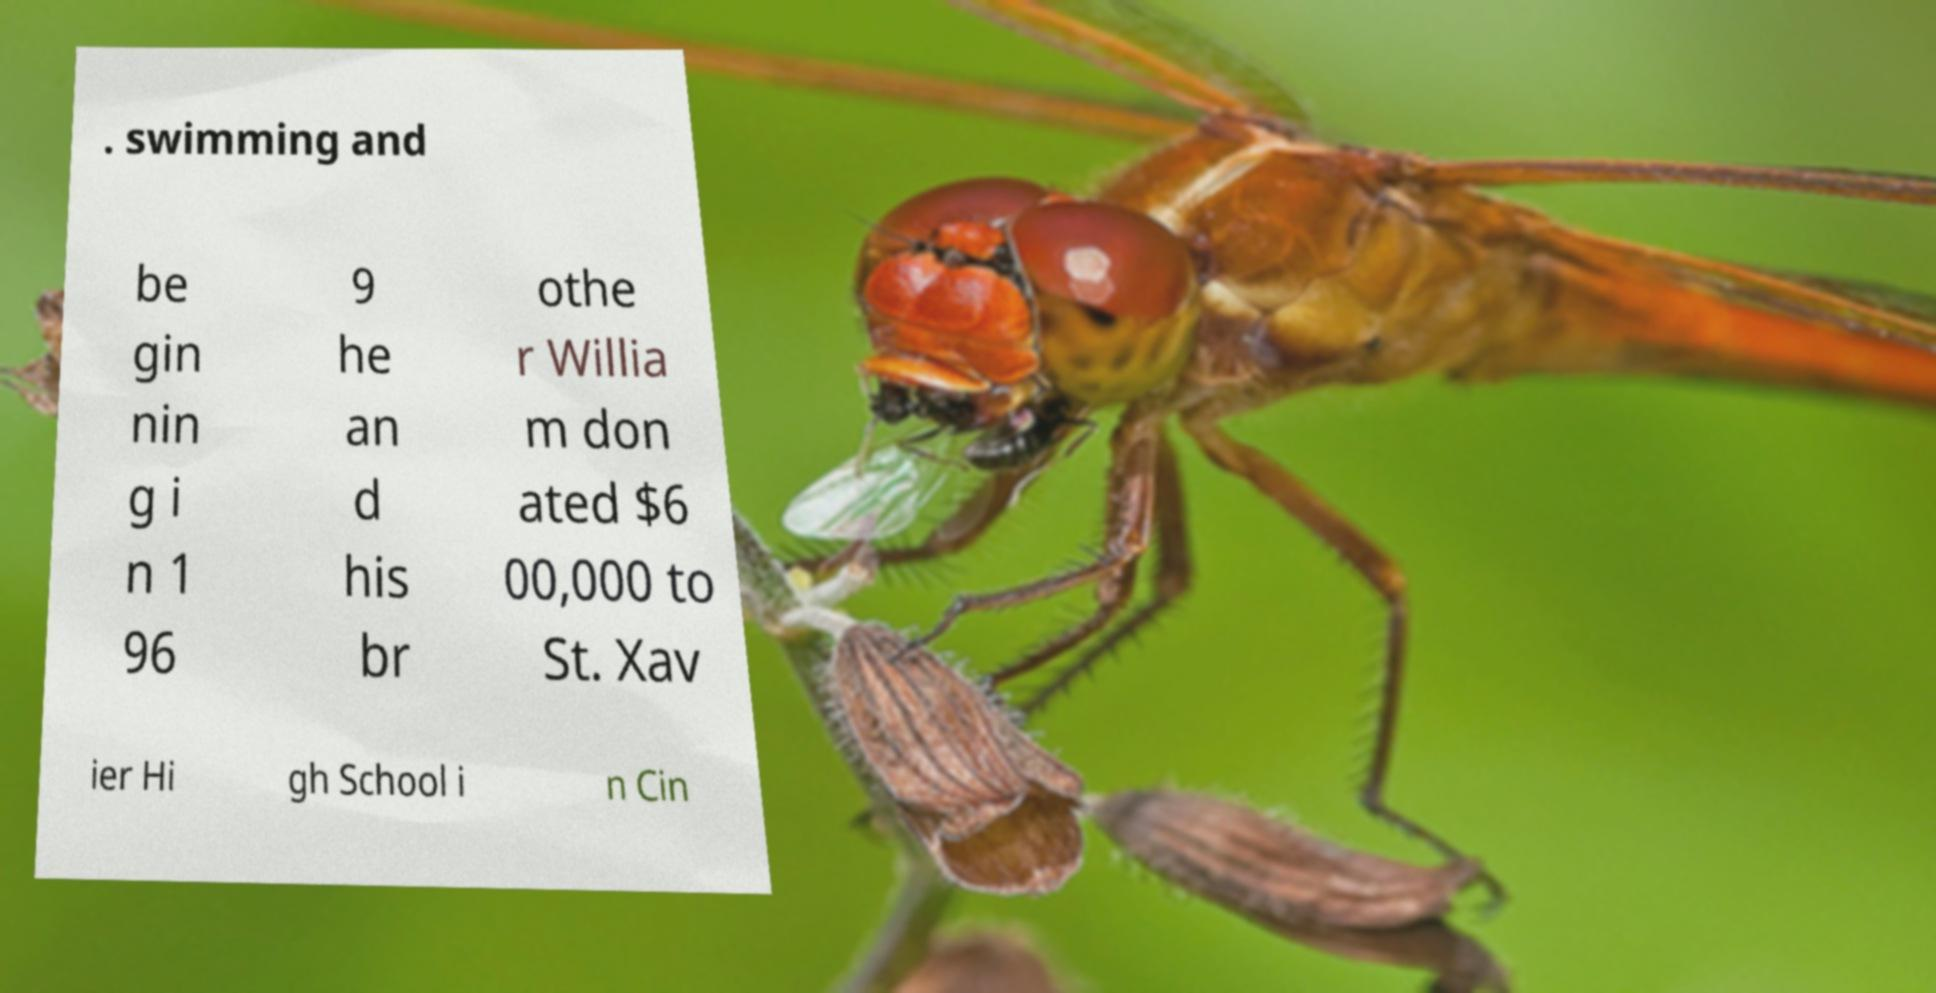For documentation purposes, I need the text within this image transcribed. Could you provide that? . swimming and be gin nin g i n 1 96 9 he an d his br othe r Willia m don ated $6 00,000 to St. Xav ier Hi gh School i n Cin 